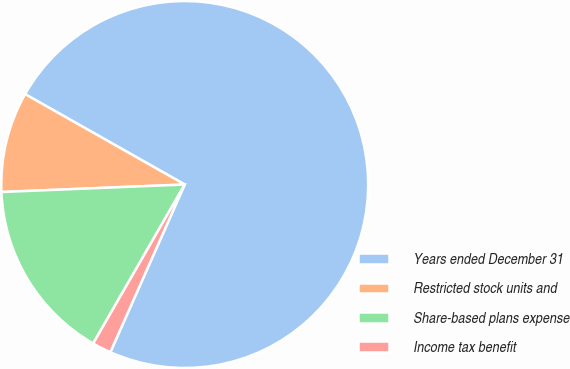Convert chart to OTSL. <chart><loc_0><loc_0><loc_500><loc_500><pie_chart><fcel>Years ended December 31<fcel>Restricted stock units and<fcel>Share-based plans expense<fcel>Income tax benefit<nl><fcel>73.44%<fcel>8.85%<fcel>16.03%<fcel>1.67%<nl></chart> 